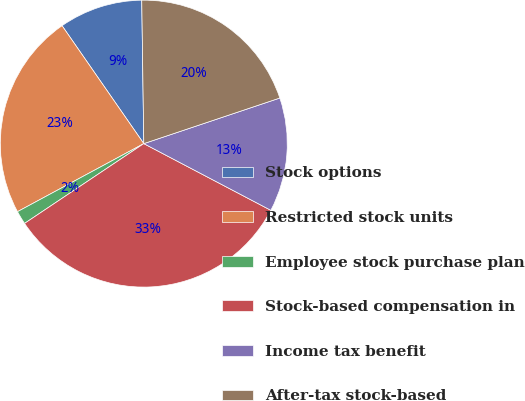Convert chart to OTSL. <chart><loc_0><loc_0><loc_500><loc_500><pie_chart><fcel>Stock options<fcel>Restricted stock units<fcel>Employee stock purchase plan<fcel>Stock-based compensation in<fcel>Income tax benefit<fcel>After-tax stock-based<nl><fcel>9.42%<fcel>23.22%<fcel>1.52%<fcel>32.92%<fcel>12.84%<fcel>20.08%<nl></chart> 